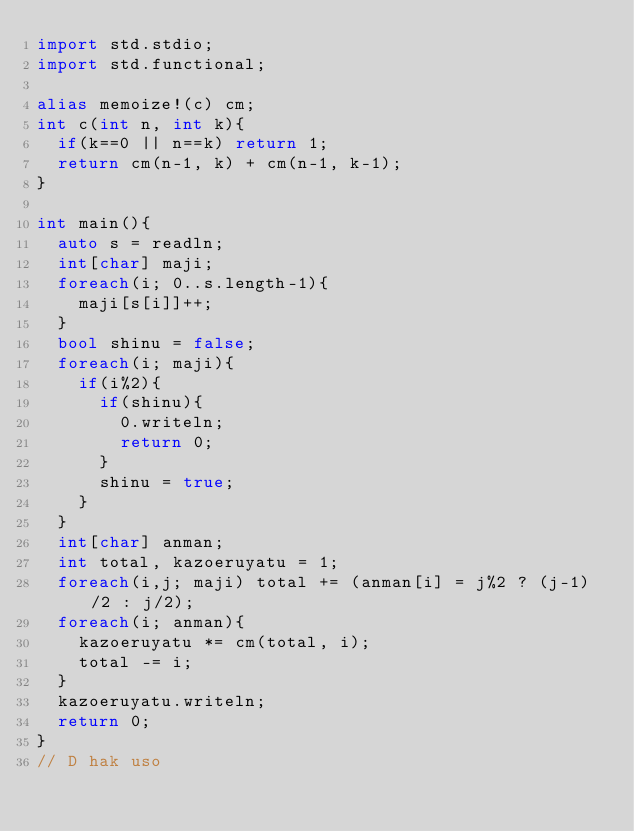Convert code to text. <code><loc_0><loc_0><loc_500><loc_500><_D_>import std.stdio;
import std.functional;

alias memoize!(c) cm;
int c(int n, int k){
	if(k==0 || n==k) return 1;
	return cm(n-1, k) + cm(n-1, k-1);
}

int main(){
	auto s = readln;
	int[char] maji;
	foreach(i; 0..s.length-1){
		maji[s[i]]++;
	}
	bool shinu = false;
	foreach(i; maji){
		if(i%2){
			if(shinu){
				0.writeln;
				return 0;
			}
			shinu = true;
		}
	}
	int[char] anman;
	int total, kazoeruyatu = 1;
	foreach(i,j; maji) total += (anman[i] = j%2 ? (j-1)/2 : j/2);
	foreach(i; anman){
		kazoeruyatu *= cm(total, i);
		total -= i;
	}
	kazoeruyatu.writeln;
	return 0;
}
// D hak uso</code> 